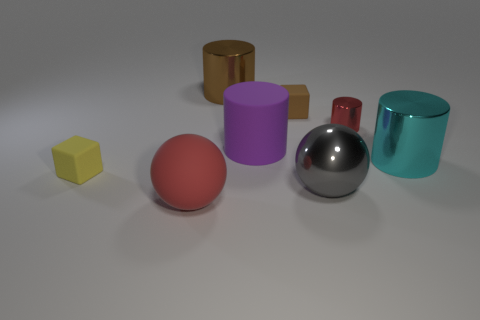Subtract all cyan cylinders. How many cylinders are left? 3 Subtract all brown cylinders. How many cylinders are left? 3 Add 1 cyan cylinders. How many objects exist? 9 Subtract all spheres. How many objects are left? 6 Subtract all red cylinders. Subtract all gray cubes. How many cylinders are left? 3 Subtract all red balls. Subtract all large red balls. How many objects are left? 6 Add 3 large matte cylinders. How many large matte cylinders are left? 4 Add 3 tiny blocks. How many tiny blocks exist? 5 Subtract 0 green cylinders. How many objects are left? 8 